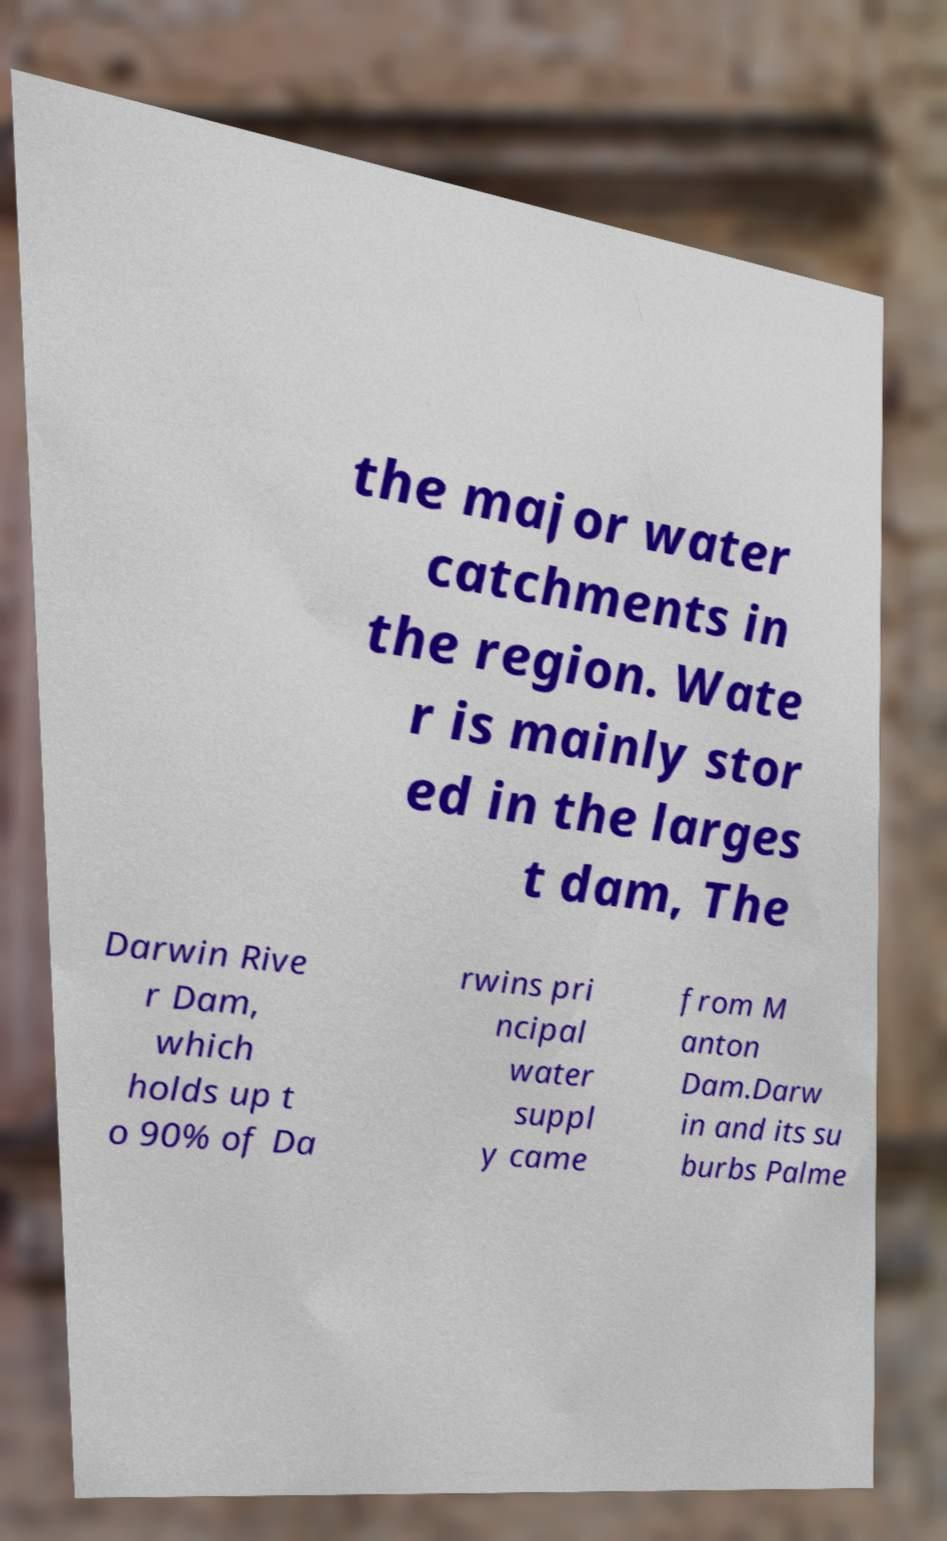There's text embedded in this image that I need extracted. Can you transcribe it verbatim? the major water catchments in the region. Wate r is mainly stor ed in the larges t dam, The Darwin Rive r Dam, which holds up t o 90% of Da rwins pri ncipal water suppl y came from M anton Dam.Darw in and its su burbs Palme 